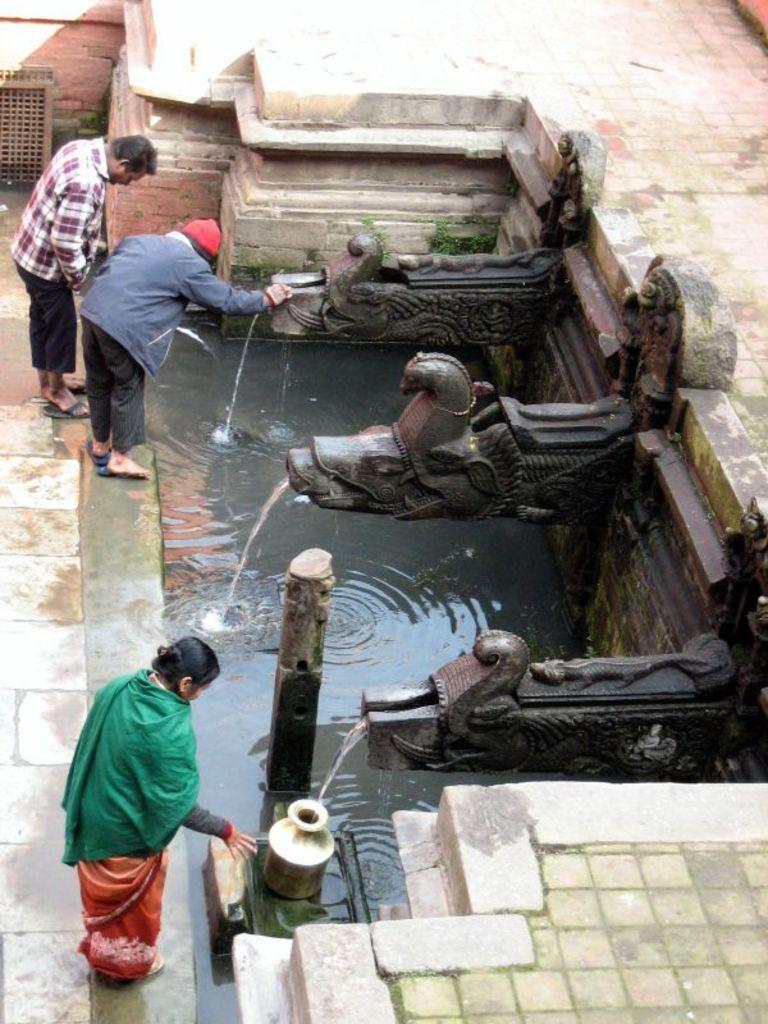Who or what can be seen in the image? There are people in the image. What is the primary element visible in the image? There is water visible in the image. What type of artwork is present in the image? There is a sculpture in the image. What type of lumber is being used by the people in the image? There is no lumber present in the image; it features people, water, and a sculpture. Can you describe the snails that are fighting in the image? There are no snails or any fighting depicted in the image. 